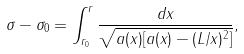<formula> <loc_0><loc_0><loc_500><loc_500>\sigma - \sigma _ { 0 } = \int _ { r _ { 0 } } ^ { r } \frac { d x } { \sqrt { a ( x ) [ a ( x ) - ( L / x ) ^ { 2 } ] } } ,</formula> 